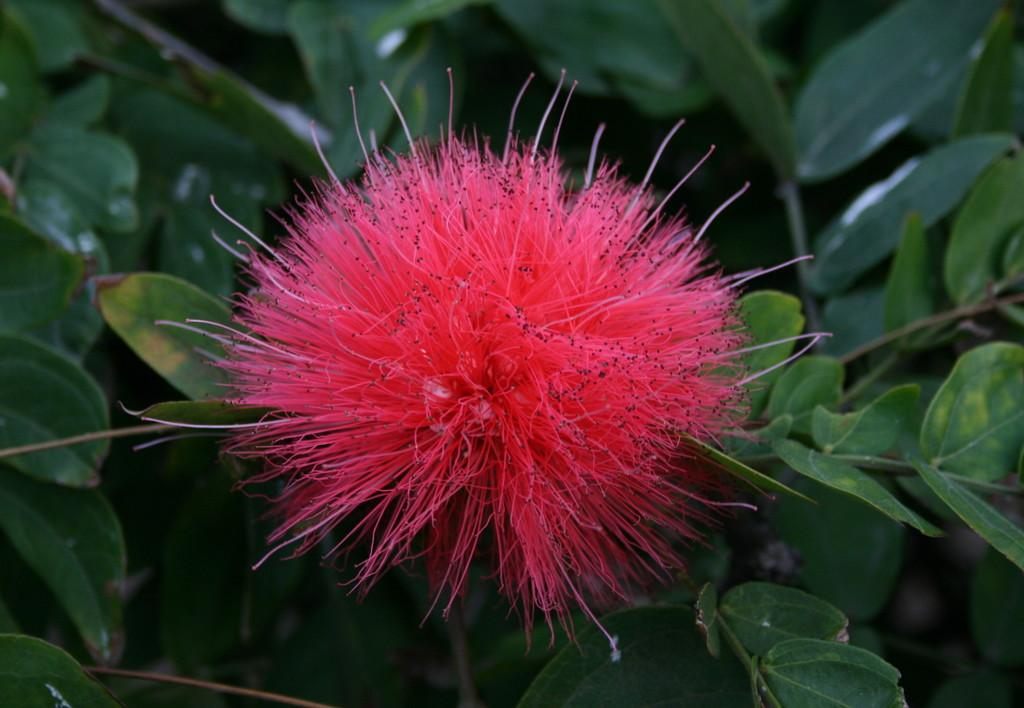What is the main subject of the image? There is a flower in the image. What color is the flower? The flower is pink in color. What else can be seen in the background of the image? There are leaves in the background of the image. Where is the mailbox located in the image? There is no mailbox present in the image. What type of expansion can be seen in the image? There is no expansion visible in the image; it features a pink flower and leaves in the background. 